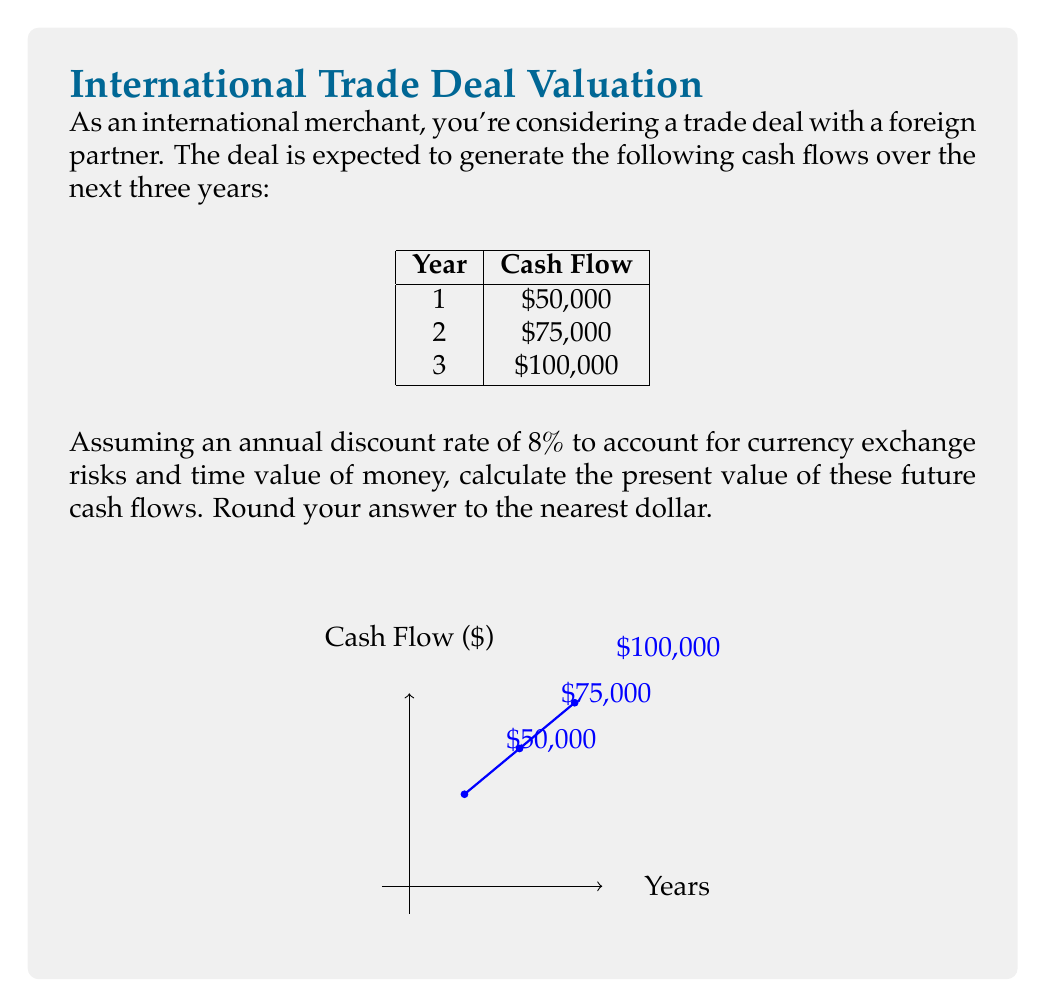Show me your answer to this math problem. To compute the present value of future cash flows, we need to discount each cash flow back to the present using the given discount rate. The formula for present value is:

$$PV = \frac{CF_t}{(1+r)^t}$$

Where:
$PV$ = Present Value
$CF_t$ = Cash Flow at time $t$
$r$ = Discount rate
$t$ = Time period

Let's calculate the present value for each year:

Year 1: $PV_1 = \frac{50,000}{(1+0.08)^1} = \frac{50,000}{1.08} = 46,296.30$

Year 2: $PV_2 = \frac{75,000}{(1+0.08)^2} = \frac{75,000}{1.1664} = 64,301.27$

Year 3: $PV_3 = \frac{100,000}{(1+0.08)^3} = \frac{100,000}{1.259712} = 79,382.28$

Now, we sum up these present values:

$Total PV = 46,296.30 + 64,301.27 + 79,382.28 = 189,979.85$

Rounding to the nearest dollar, we get $189,980.
Answer: $189,980 